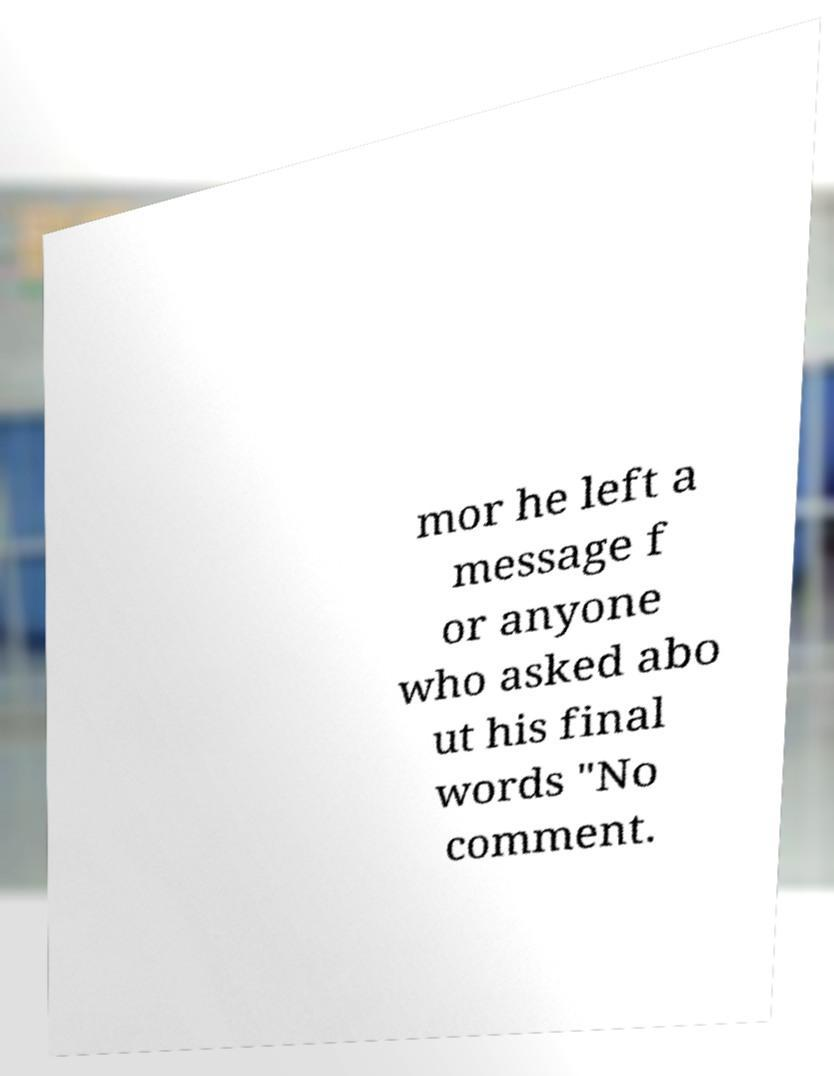What messages or text are displayed in this image? I need them in a readable, typed format. mor he left a message f or anyone who asked abo ut his final words "No comment. 